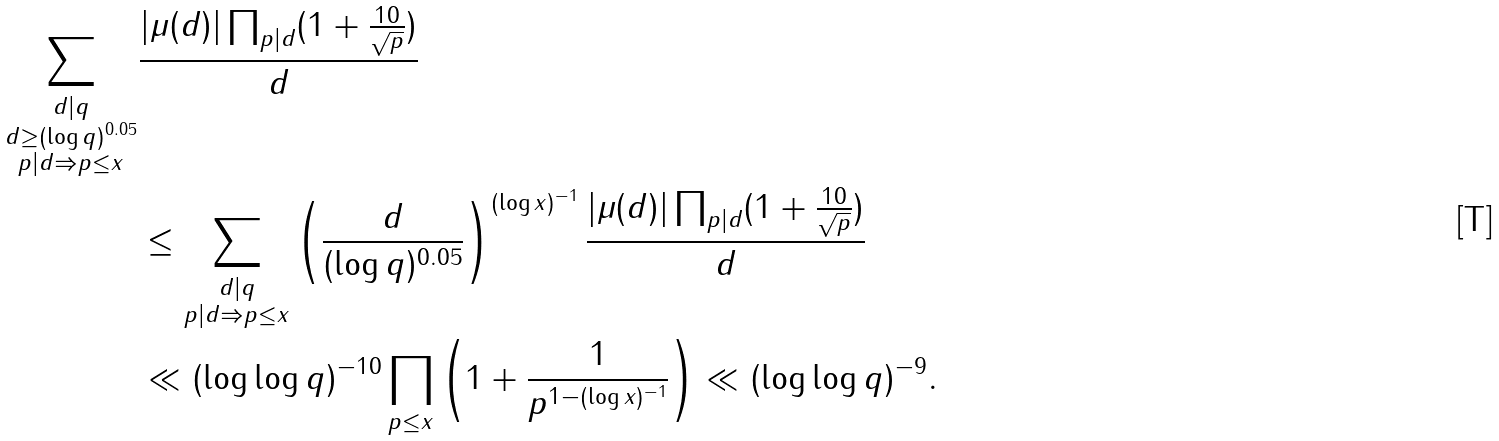<formula> <loc_0><loc_0><loc_500><loc_500>\sum _ { \substack { d | q \\ d \geq ( \log q ) ^ { 0 . 0 5 } \\ p | d \Rightarrow p \leq x } } & \frac { | \mu ( d ) | \prod _ { p | d } ( 1 + \frac { 1 0 } { \sqrt { p } } ) } { d } \\ & \leq \sum _ { \substack { d | q \\ p | d \Rightarrow p \leq x } } \left ( \frac { d } { ( \log q ) ^ { 0 . 0 5 } } \right ) ^ { ( \log x ) ^ { - 1 } } \frac { | \mu ( d ) | \prod _ { p | d } ( 1 + \frac { 1 0 } { \sqrt { p } } ) } { d } \\ & \ll ( \log \log q ) ^ { - 1 0 } \prod _ { p \leq x } \left ( 1 + \frac { 1 } { p ^ { 1 - ( \log x ) ^ { - 1 } } } \right ) \ll ( \log \log q ) ^ { - 9 } .</formula> 